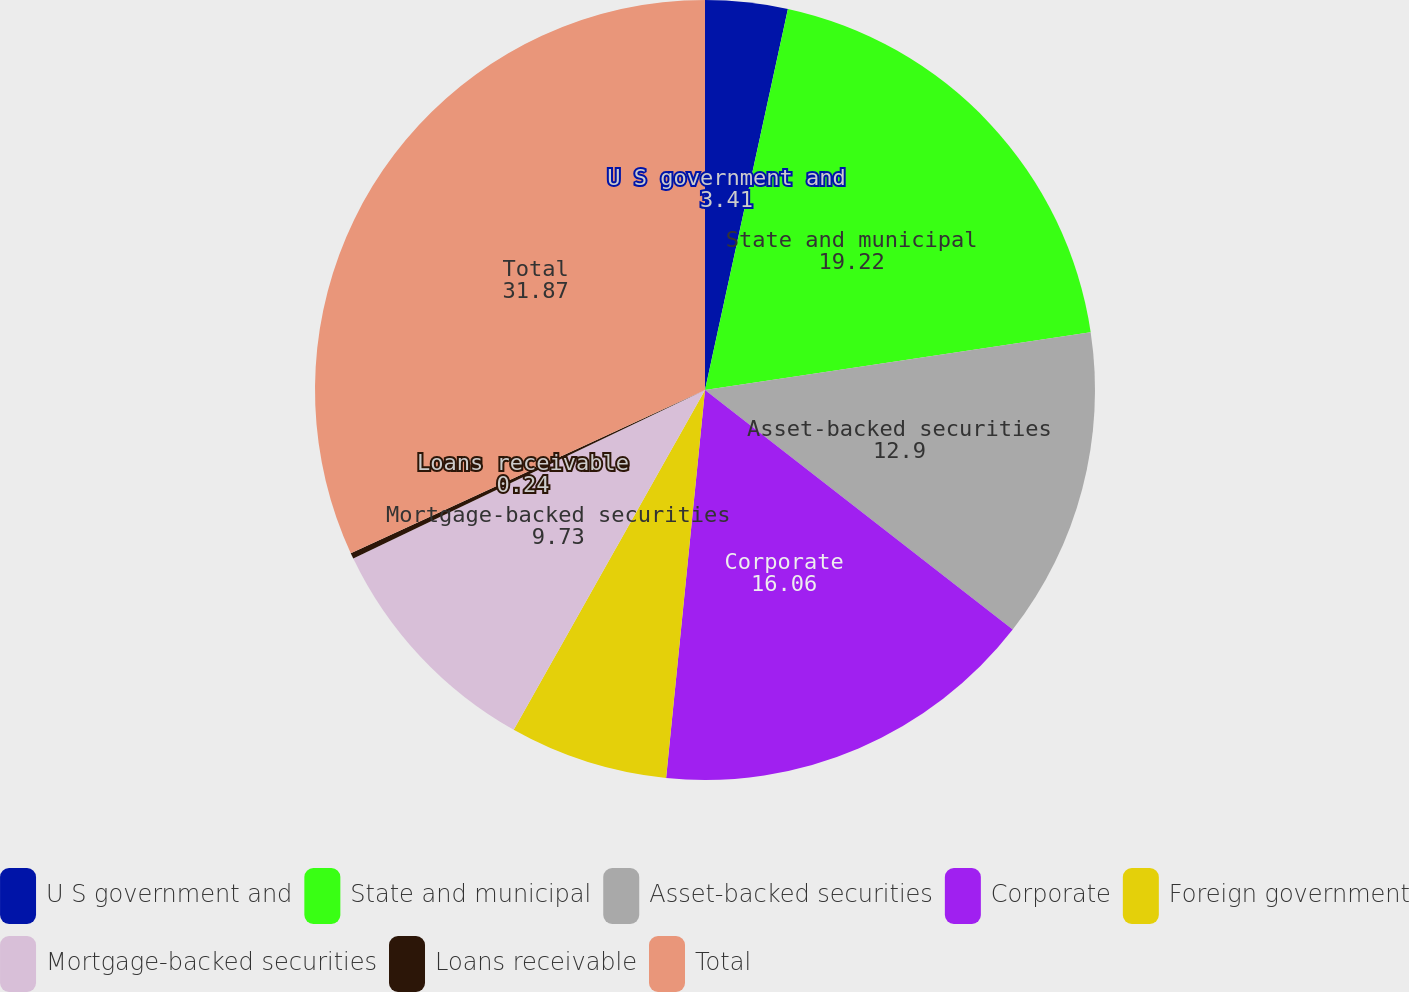Convert chart. <chart><loc_0><loc_0><loc_500><loc_500><pie_chart><fcel>U S government and<fcel>State and municipal<fcel>Asset-backed securities<fcel>Corporate<fcel>Foreign government<fcel>Mortgage-backed securities<fcel>Loans receivable<fcel>Total<nl><fcel>3.41%<fcel>19.22%<fcel>12.9%<fcel>16.06%<fcel>6.57%<fcel>9.73%<fcel>0.24%<fcel>31.87%<nl></chart> 